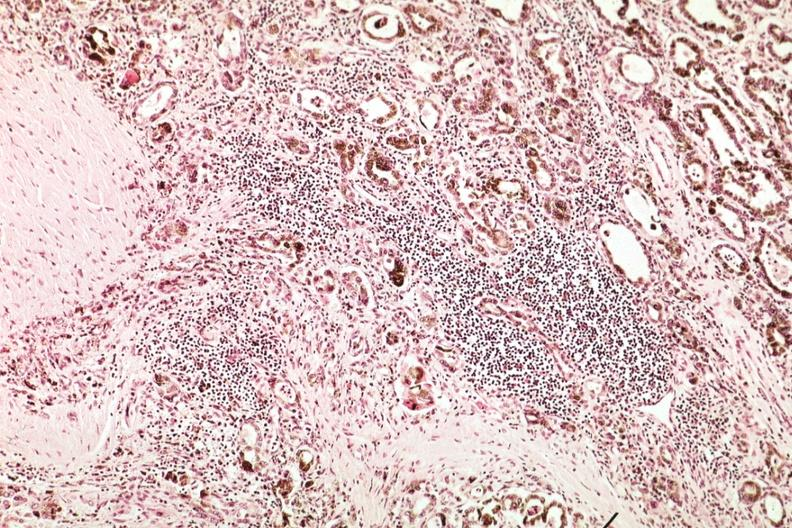s hemochromatosis present?
Answer the question using a single word or phrase. Yes 